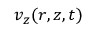Convert formula to latex. <formula><loc_0><loc_0><loc_500><loc_500>v _ { z } ( r , z , t )</formula> 